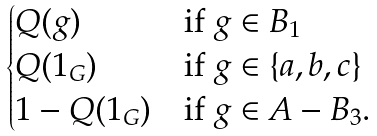Convert formula to latex. <formula><loc_0><loc_0><loc_500><loc_500>\begin{cases} Q ( g ) & \text {if } g \in B _ { 1 } \\ Q ( 1 _ { G } ) & \text {if } g \in \{ a , b , c \} \\ 1 - Q ( 1 _ { G } ) & \text {if } g \in A - B _ { 3 } . \end{cases}</formula> 